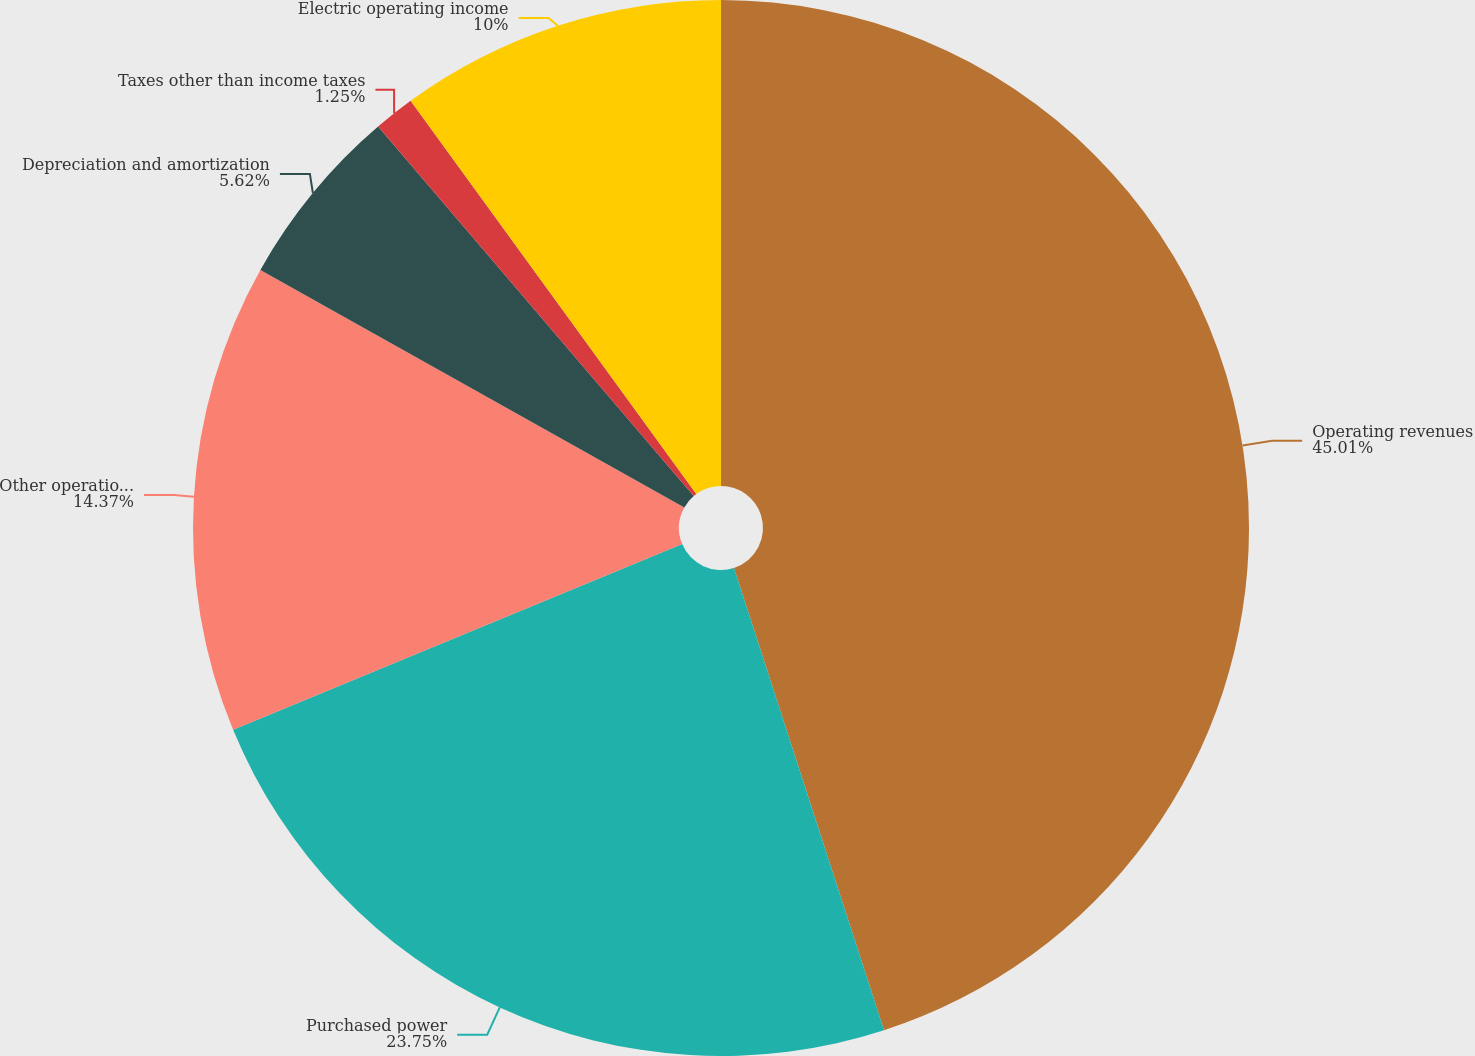Convert chart to OTSL. <chart><loc_0><loc_0><loc_500><loc_500><pie_chart><fcel>Operating revenues<fcel>Purchased power<fcel>Other operations and<fcel>Depreciation and amortization<fcel>Taxes other than income taxes<fcel>Electric operating income<nl><fcel>45.0%<fcel>23.75%<fcel>14.37%<fcel>5.62%<fcel>1.25%<fcel>10.0%<nl></chart> 